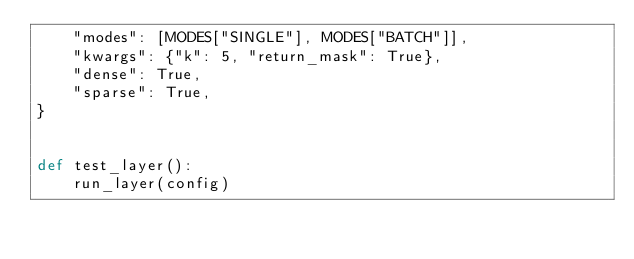Convert code to text. <code><loc_0><loc_0><loc_500><loc_500><_Python_>    "modes": [MODES["SINGLE"], MODES["BATCH"]],
    "kwargs": {"k": 5, "return_mask": True},
    "dense": True,
    "sparse": True,
}


def test_layer():
    run_layer(config)
</code> 